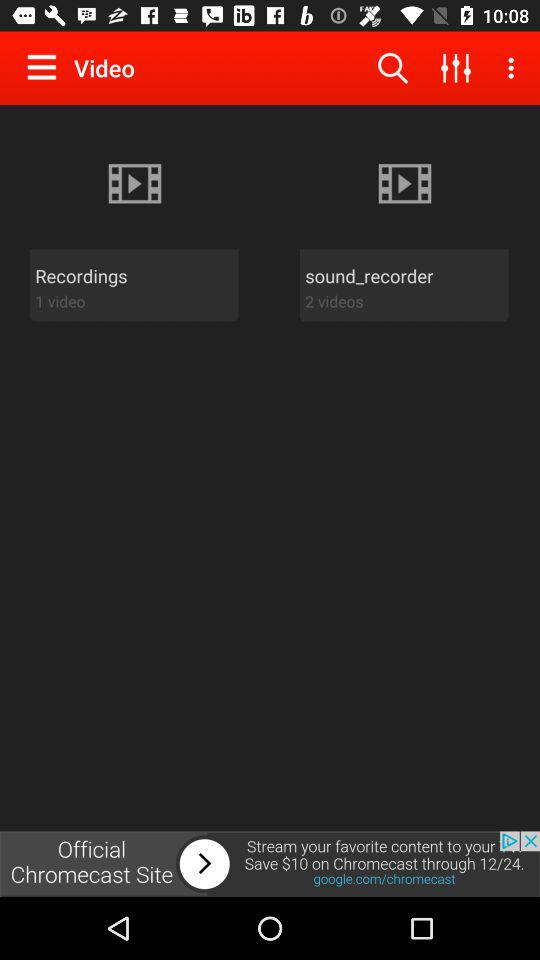How many videos are in total?
Answer the question using a single word or phrase. 3 